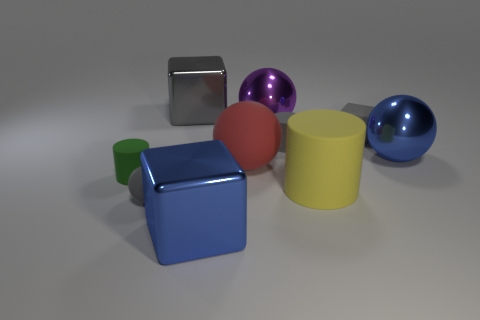What material is the large block that is behind the yellow matte thing?
Offer a very short reply. Metal. Is the shape of the large red matte thing the same as the big blue thing that is in front of the green rubber thing?
Offer a very short reply. No. There is a small object that is behind the small sphere and left of the blue cube; what material is it?
Offer a very short reply. Rubber. There is another metal sphere that is the same size as the purple metal ball; what color is it?
Offer a very short reply. Blue. Is the material of the big gray cube the same as the tiny gray object that is in front of the big matte cylinder?
Your response must be concise. No. What number of other objects are there of the same size as the yellow rubber object?
Your answer should be very brief. 5. There is a large cylinder to the right of the big object in front of the yellow matte cylinder; is there a small gray block that is to the left of it?
Provide a short and direct response. No. The red matte sphere is what size?
Your answer should be compact. Large. What is the size of the blue object behind the green rubber cylinder?
Your answer should be very brief. Large. There is a sphere that is in front of the yellow cylinder; does it have the same size as the blue metal ball?
Provide a short and direct response. No. 